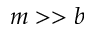<formula> <loc_0><loc_0><loc_500><loc_500>m > > b</formula> 